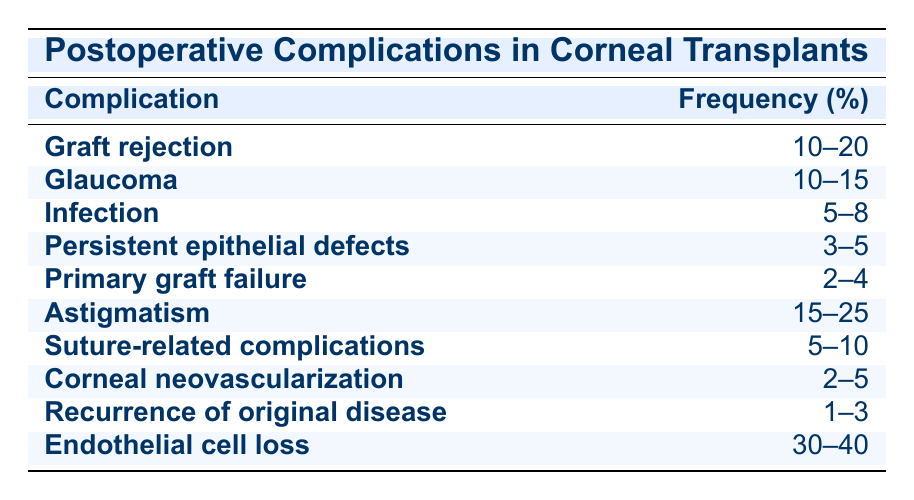What is the frequency of endothelial cell loss? The table lists the frequency of endothelial cell loss as 30-40%. This value can be found directly in the corresponding row in the "Frequency (%)" column.
Answer: 30-40% Which complication has a frequency of 10-20%? The table shows graft rejection listed under the complication category with a frequency of 10-20%. This information is located in its respective row.
Answer: Graft rejection What is the difference in frequency between astigmatism and infection? To find the difference, we identify the frequencies: astigmatism is 15-25% and infection is 5-8%. The average for astigmatism could be around 20%, and for infection around 6.5%. The difference is approximately 20 - 6.5 = 13.5%.
Answer: Approximately 13.5% Is the frequency of recurrence of original disease greater than that of primary graft failure? The recurrence of original disease has a frequency of 1-3% while primary graft failure has a frequency of 2-4%. The highest value of recurrence (3%) is still less than the lowest value of primary graft failure (2%). Thus, the statement is false.
Answer: No What is the total range of frequencies for glaucoma and suture-related complications? The frequency for glaucoma is 10-15% and for suture-related complications is 5-10%. Combining these ranges gives: lower bound = 10 + 5 = 15% and upper bound = 15 + 10 = 25%. Therefore, the total range of frequencies is 15-25%.
Answer: 15-25% Which complication has the lowest frequency? The table indicates that recurrence of original disease has the lowest frequency range of 1-3%. This can be determined by comparing the frequency ranges of each complication listed.
Answer: Recurrence of original disease What is the average frequency of persistent epithelial defects and primary graft failure? The average frequency of persistent epithelial defects is around 4% (3-5%) and for primary graft failure it is around 3% (2-4%). Adding these averages gives 4 + 3 = 7%, and dividing by 2 yields an average of 3.5%.
Answer: 3.5% Does graft rejection occur more frequently than corneal neovascularization? Graft rejection has a frequency of 10-20%, while corneal neovascularization has a frequency of 2-5%. Since 10% (the lower limit of graft rejection) is greater than 5% (the upper limit of corneal neovascularization), the statement is true.
Answer: Yes 